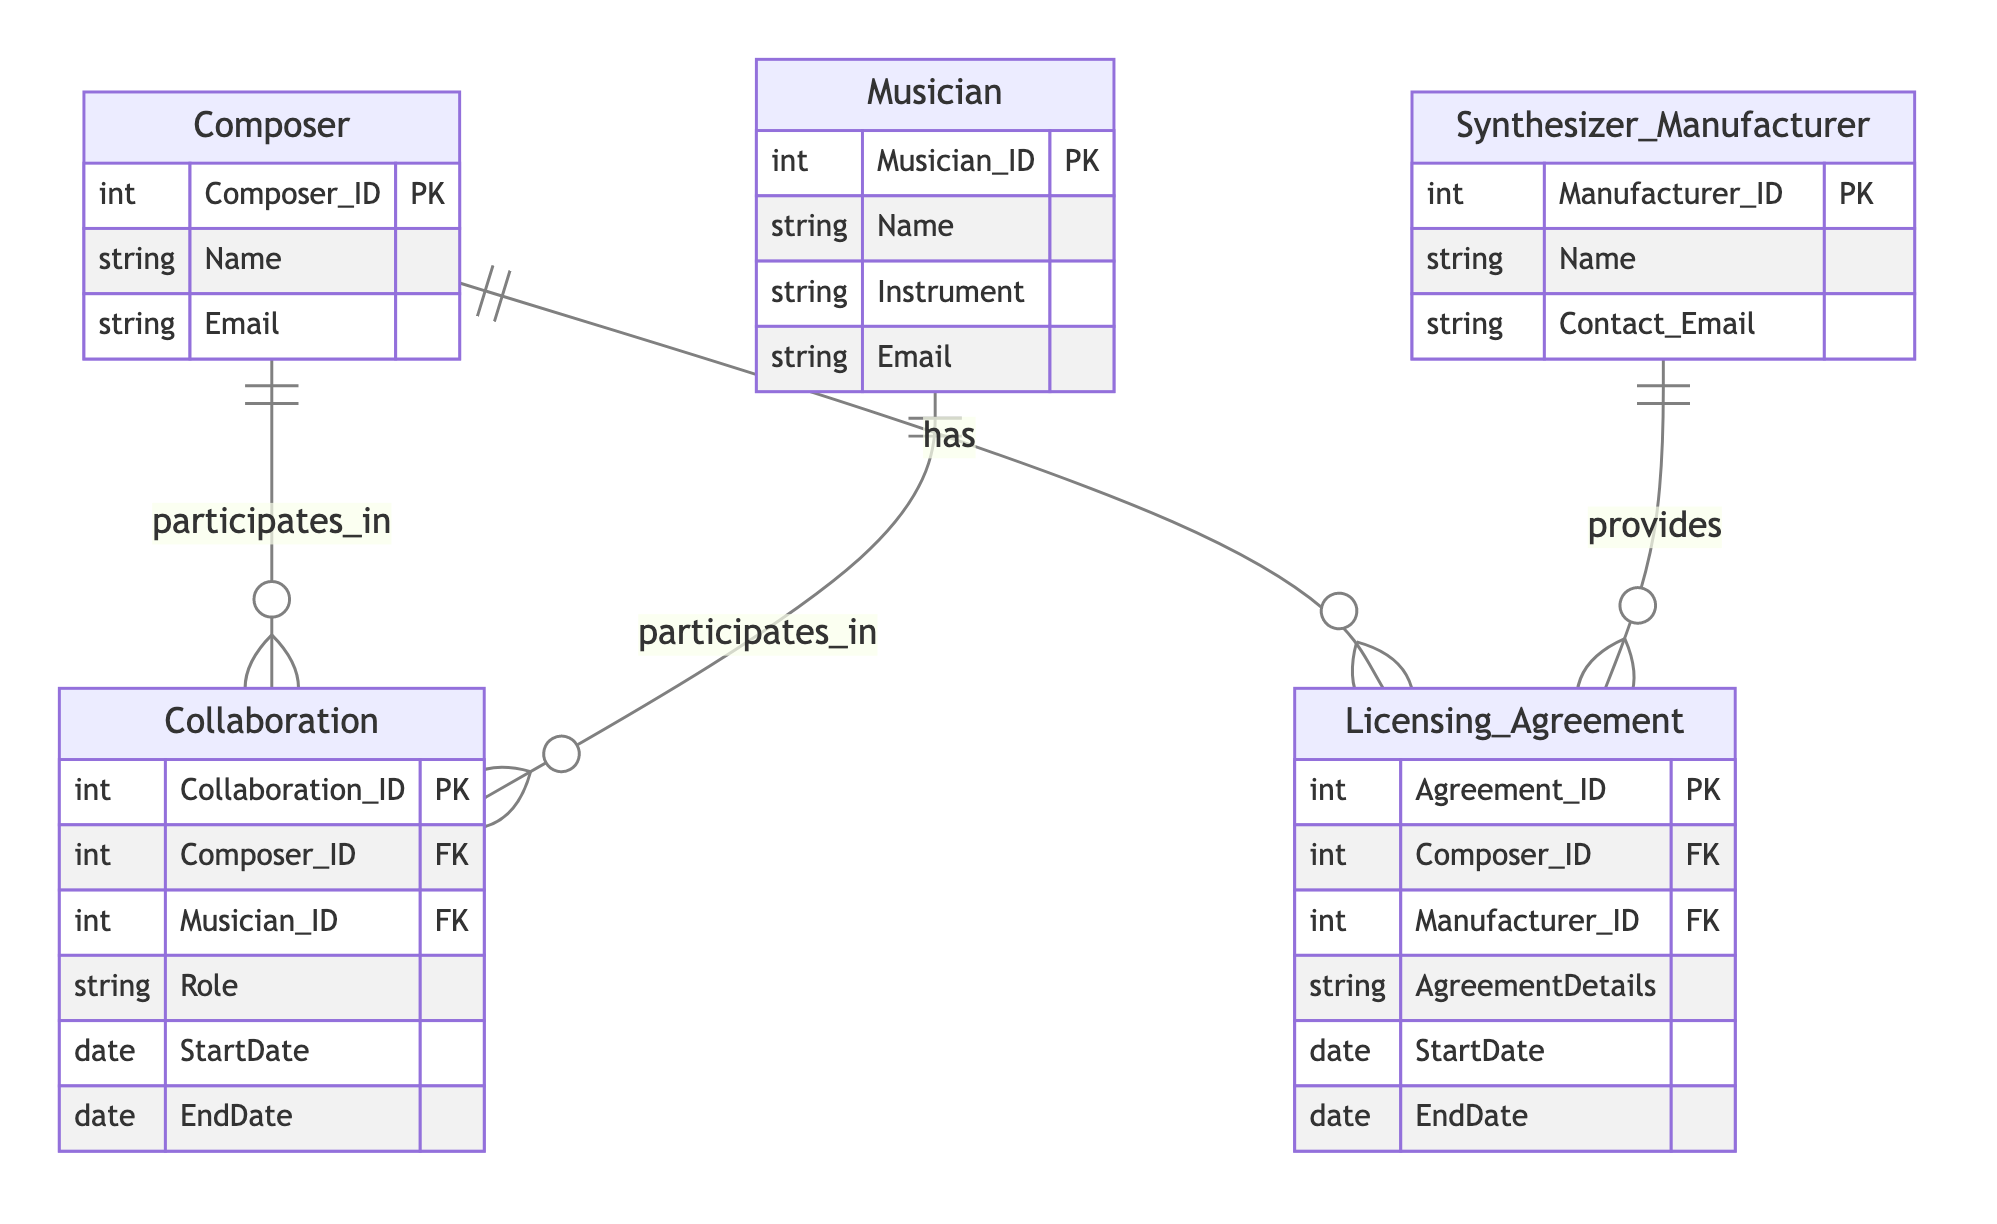What is the primary key of the Composer entity? The primary key in the Composer entity is "Composer_ID," which uniquely identifies each composer in the database.
Answer: Composer_ID How many relationships are there between Composer and Musician? There is one relationship called "Composer_Collaborates_With_Musician," indicating that each composer can collaborate with multiple musicians through the Collaboration entity.
Answer: One What type of relationship exists between Composer and Synthesizer Manufacturer? The relationship is described as "Composer_Has_Licensing_Agreement_With_Manufacturer," which shows a one-to-many relationship where a composer can have multiple licensing agreements with manufacturers.
Answer: One-to-many What attribute in the Licensing Agreement entity describes the details of the agreement? The attribute "AgreementDetails" provides specific information about the licensing agreement between a composer and a synthesizer manufacturer.
Answer: AgreementDetails What is the maximum number of collaborations a single Composer can have? A composer can have multiple collaborations with musicians, but there isn't a predefined maximum in the diagram; it is dictated by the number of musicians and arrangements made. Thus, theoretically, it is unbounded or dependent on circumstances.
Answer: Unbounded Which entity has the "Instrument" attribute? The "Musician" entity includes the "Instrument" attribute, which specifies the instrument played by each musician.
Answer: Musician What is the foreign key that connects Collaboration to Composer? The connecting foreign key from the Collaboration entity to the Composer entity is "Composer_ID." This allows the relationship to link back to the composer involved in a collaboration.
Answer: Composer_ID How many primary keys are there in the Licensing Agreement entity? There is one primary key in the Licensing Agreement entity, which is "Agreement_ID," making it unique for each licensing agreement.
Answer: One What is the role of the Synthesizer Manufacturer in the Licensing Agreement? The Synthesizer Manufacturer provides the licenses required for the composer to use their synthesizers, represented in the Licensing Agreement relationship.
Answer: Provides 